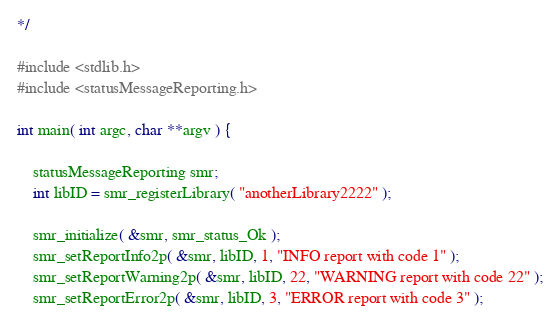<code> <loc_0><loc_0><loc_500><loc_500><_C_>*/

#include <stdlib.h>
#include <statusMessageReporting.h>

int main( int argc, char **argv ) {

	statusMessageReporting smr;
   	int libID = smr_registerLibrary( "anotherLibrary2222" );

   	smr_initialize( &smr, smr_status_Ok );
   	smr_setReportInfo2p( &smr, libID, 1, "INFO report with code 1" );
   	smr_setReportWarning2p( &smr, libID, 22, "WARNING report with code 22" );
   	smr_setReportError2p( &smr, libID, 3, "ERROR report with code 3" );</code> 